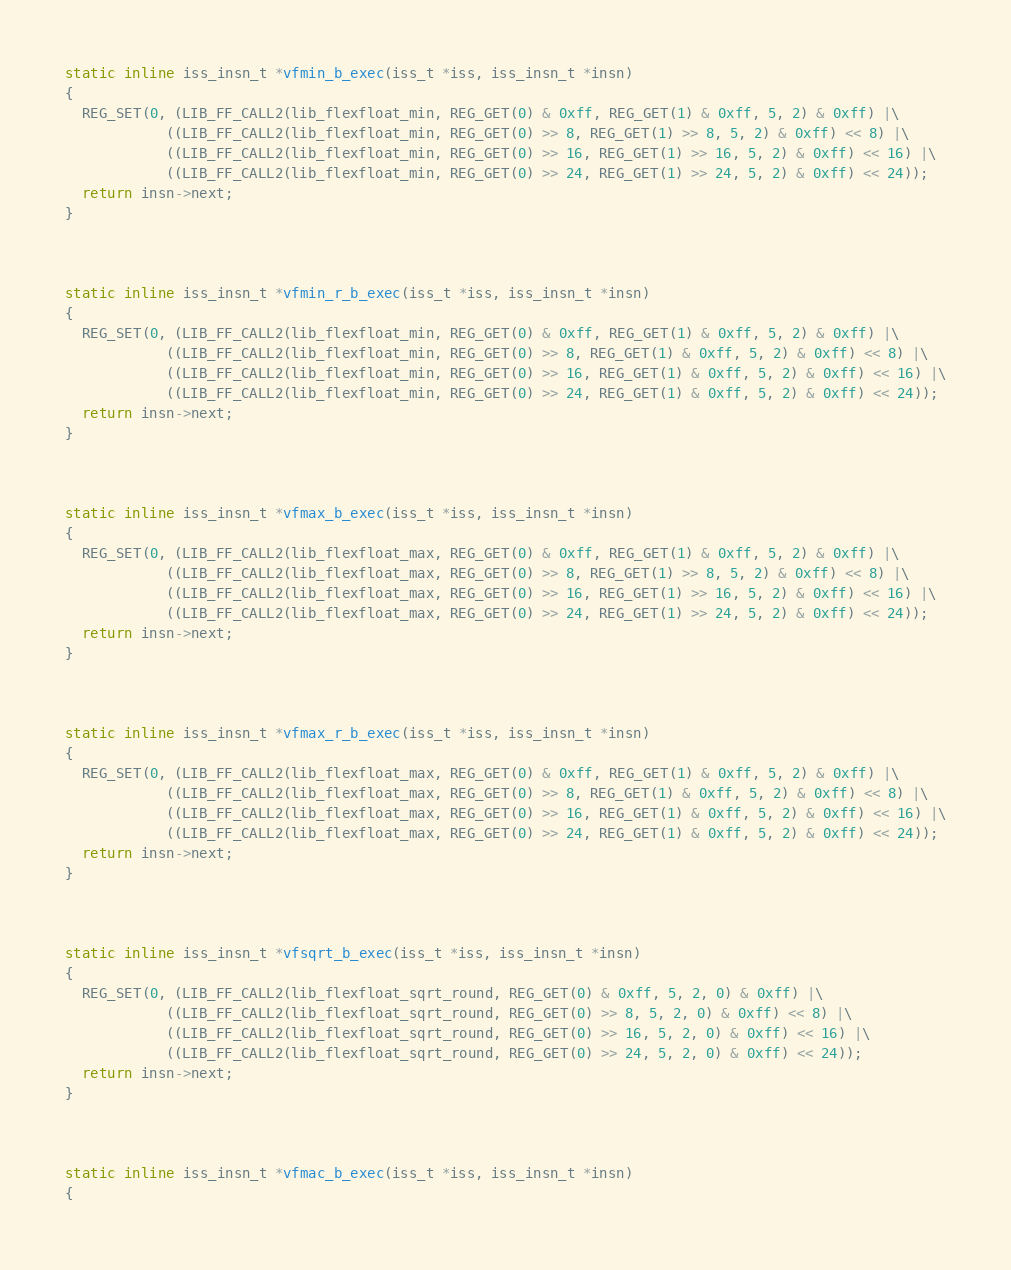<code> <loc_0><loc_0><loc_500><loc_500><_C++_>


static inline iss_insn_t *vfmin_b_exec(iss_t *iss, iss_insn_t *insn)
{
  REG_SET(0, (LIB_FF_CALL2(lib_flexfloat_min, REG_GET(0) & 0xff, REG_GET(1) & 0xff, 5, 2) & 0xff) |\
            ((LIB_FF_CALL2(lib_flexfloat_min, REG_GET(0) >> 8, REG_GET(1) >> 8, 5, 2) & 0xff) << 8) |\
            ((LIB_FF_CALL2(lib_flexfloat_min, REG_GET(0) >> 16, REG_GET(1) >> 16, 5, 2) & 0xff) << 16) |\
            ((LIB_FF_CALL2(lib_flexfloat_min, REG_GET(0) >> 24, REG_GET(1) >> 24, 5, 2) & 0xff) << 24));
  return insn->next;
}



static inline iss_insn_t *vfmin_r_b_exec(iss_t *iss, iss_insn_t *insn)
{
  REG_SET(0, (LIB_FF_CALL2(lib_flexfloat_min, REG_GET(0) & 0xff, REG_GET(1) & 0xff, 5, 2) & 0xff) |\
            ((LIB_FF_CALL2(lib_flexfloat_min, REG_GET(0) >> 8, REG_GET(1) & 0xff, 5, 2) & 0xff) << 8) |\
            ((LIB_FF_CALL2(lib_flexfloat_min, REG_GET(0) >> 16, REG_GET(1) & 0xff, 5, 2) & 0xff) << 16) |\
            ((LIB_FF_CALL2(lib_flexfloat_min, REG_GET(0) >> 24, REG_GET(1) & 0xff, 5, 2) & 0xff) << 24));
  return insn->next;
}



static inline iss_insn_t *vfmax_b_exec(iss_t *iss, iss_insn_t *insn)
{
  REG_SET(0, (LIB_FF_CALL2(lib_flexfloat_max, REG_GET(0) & 0xff, REG_GET(1) & 0xff, 5, 2) & 0xff) |\
            ((LIB_FF_CALL2(lib_flexfloat_max, REG_GET(0) >> 8, REG_GET(1) >> 8, 5, 2) & 0xff) << 8) |\
            ((LIB_FF_CALL2(lib_flexfloat_max, REG_GET(0) >> 16, REG_GET(1) >> 16, 5, 2) & 0xff) << 16) |\
            ((LIB_FF_CALL2(lib_flexfloat_max, REG_GET(0) >> 24, REG_GET(1) >> 24, 5, 2) & 0xff) << 24));
  return insn->next;
}



static inline iss_insn_t *vfmax_r_b_exec(iss_t *iss, iss_insn_t *insn)
{
  REG_SET(0, (LIB_FF_CALL2(lib_flexfloat_max, REG_GET(0) & 0xff, REG_GET(1) & 0xff, 5, 2) & 0xff) |\
            ((LIB_FF_CALL2(lib_flexfloat_max, REG_GET(0) >> 8, REG_GET(1) & 0xff, 5, 2) & 0xff) << 8) |\
            ((LIB_FF_CALL2(lib_flexfloat_max, REG_GET(0) >> 16, REG_GET(1) & 0xff, 5, 2) & 0xff) << 16) |\
            ((LIB_FF_CALL2(lib_flexfloat_max, REG_GET(0) >> 24, REG_GET(1) & 0xff, 5, 2) & 0xff) << 24));
  return insn->next;
}



static inline iss_insn_t *vfsqrt_b_exec(iss_t *iss, iss_insn_t *insn)
{
  REG_SET(0, (LIB_FF_CALL2(lib_flexfloat_sqrt_round, REG_GET(0) & 0xff, 5, 2, 0) & 0xff) |\
            ((LIB_FF_CALL2(lib_flexfloat_sqrt_round, REG_GET(0) >> 8, 5, 2, 0) & 0xff) << 8) |\
            ((LIB_FF_CALL2(lib_flexfloat_sqrt_round, REG_GET(0) >> 16, 5, 2, 0) & 0xff) << 16) |\
            ((LIB_FF_CALL2(lib_flexfloat_sqrt_round, REG_GET(0) >> 24, 5, 2, 0) & 0xff) << 24));
  return insn->next;
}



static inline iss_insn_t *vfmac_b_exec(iss_t *iss, iss_insn_t *insn)
{</code> 